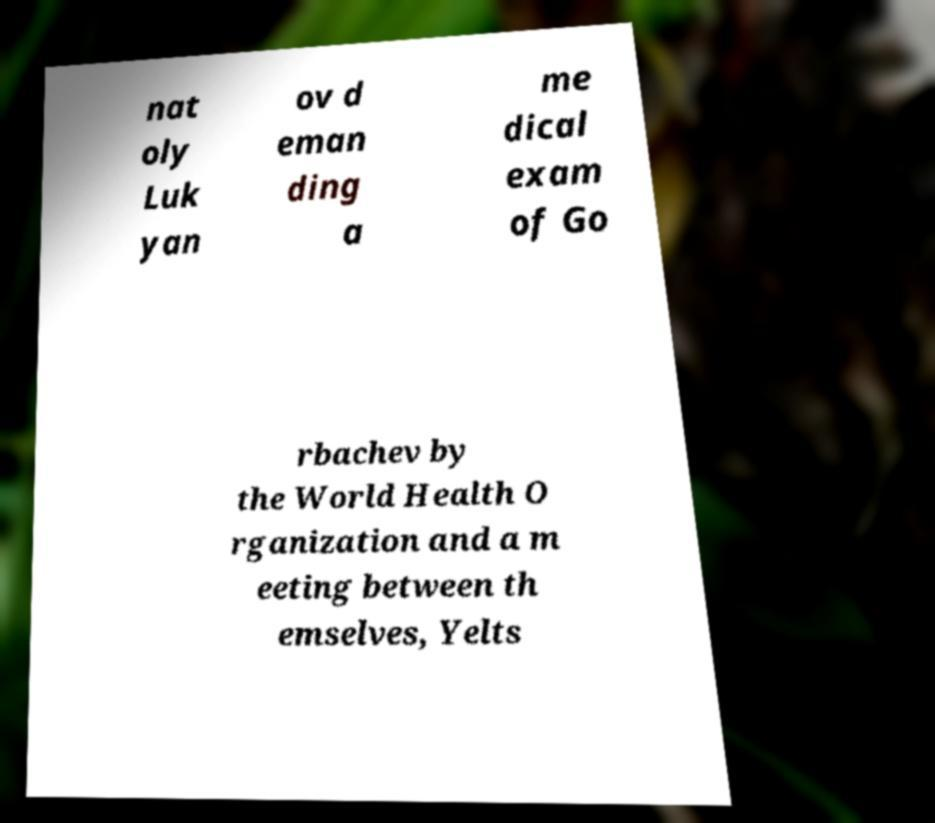There's text embedded in this image that I need extracted. Can you transcribe it verbatim? nat oly Luk yan ov d eman ding a me dical exam of Go rbachev by the World Health O rganization and a m eeting between th emselves, Yelts 